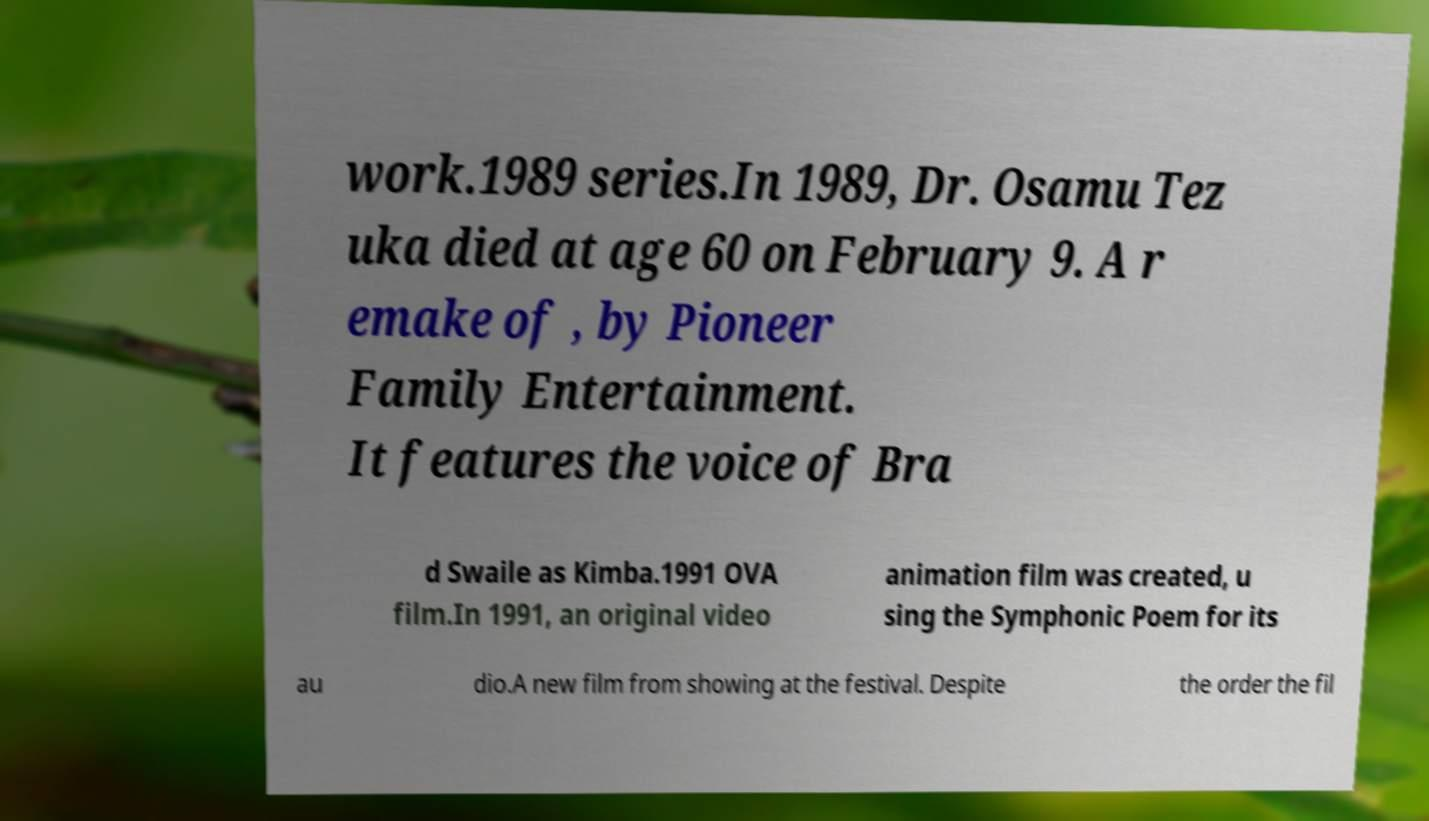I need the written content from this picture converted into text. Can you do that? work.1989 series.In 1989, Dr. Osamu Tez uka died at age 60 on February 9. A r emake of , by Pioneer Family Entertainment. It features the voice of Bra d Swaile as Kimba.1991 OVA film.In 1991, an original video animation film was created, u sing the Symphonic Poem for its au dio.A new film from showing at the festival. Despite the order the fil 